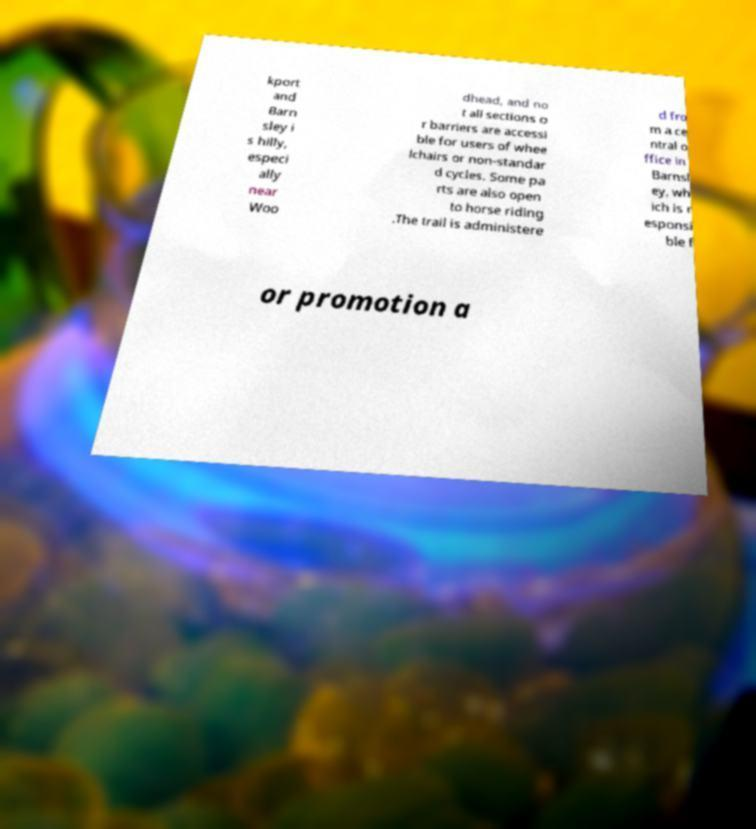Could you assist in decoding the text presented in this image and type it out clearly? kport and Barn sley i s hilly, especi ally near Woo dhead, and no t all sections o r barriers are accessi ble for users of whee lchairs or non-standar d cycles. Some pa rts are also open to horse riding .The trail is administere d fro m a ce ntral o ffice in Barnsl ey, wh ich is r esponsi ble f or promotion a 